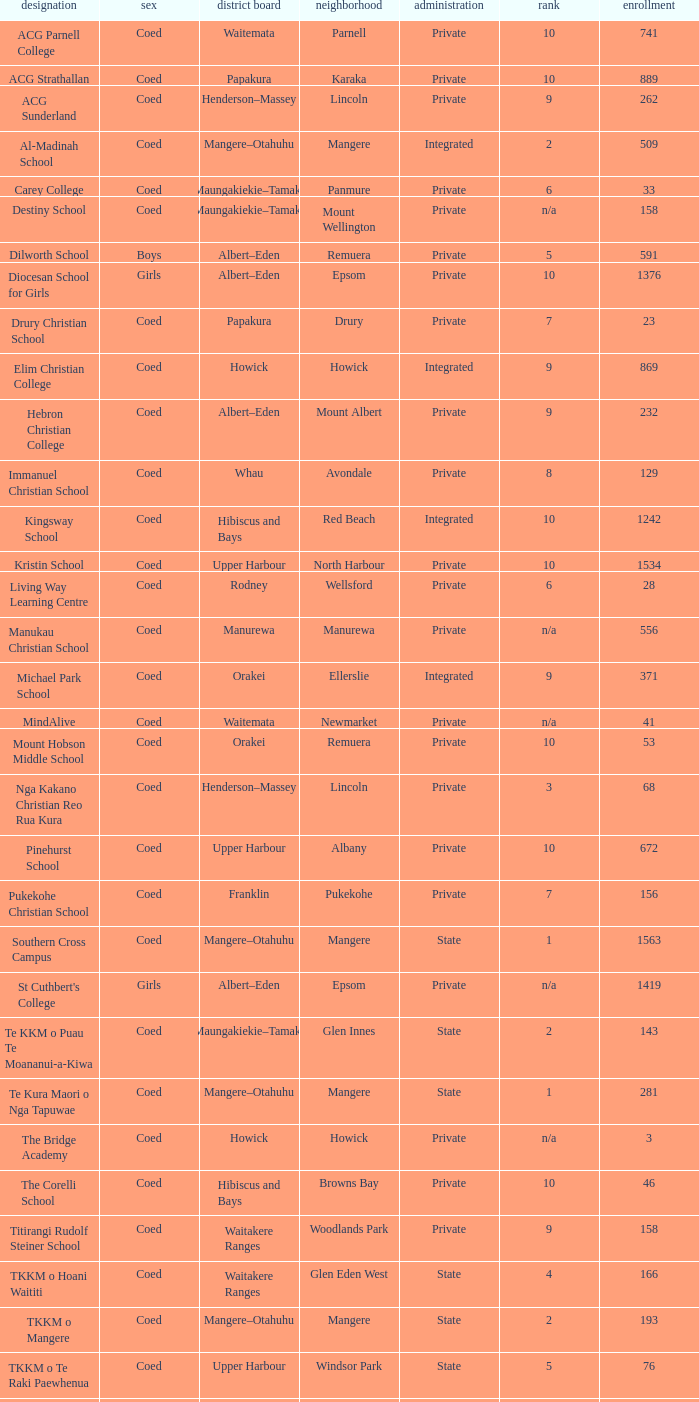What is the name when the local board is albert–eden, and a Decile of 9? Hebron Christian College. 